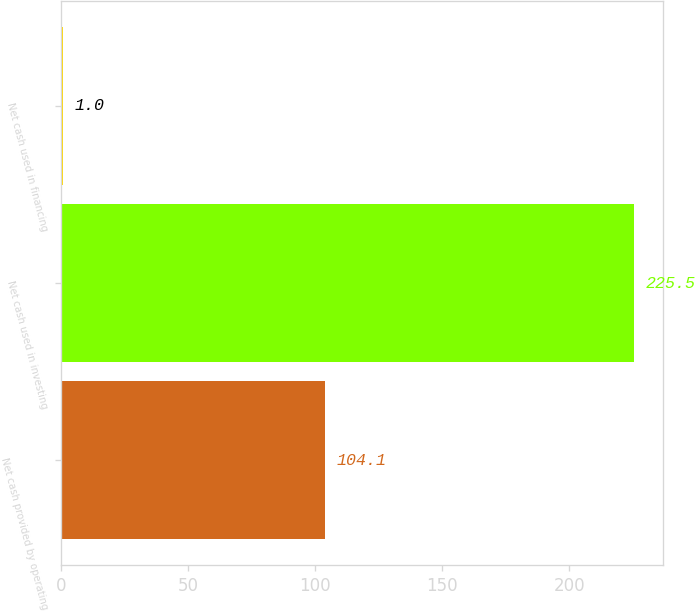Convert chart to OTSL. <chart><loc_0><loc_0><loc_500><loc_500><bar_chart><fcel>Net cash provided by operating<fcel>Net cash used in investing<fcel>Net cash used in financing<nl><fcel>104.1<fcel>225.5<fcel>1<nl></chart> 